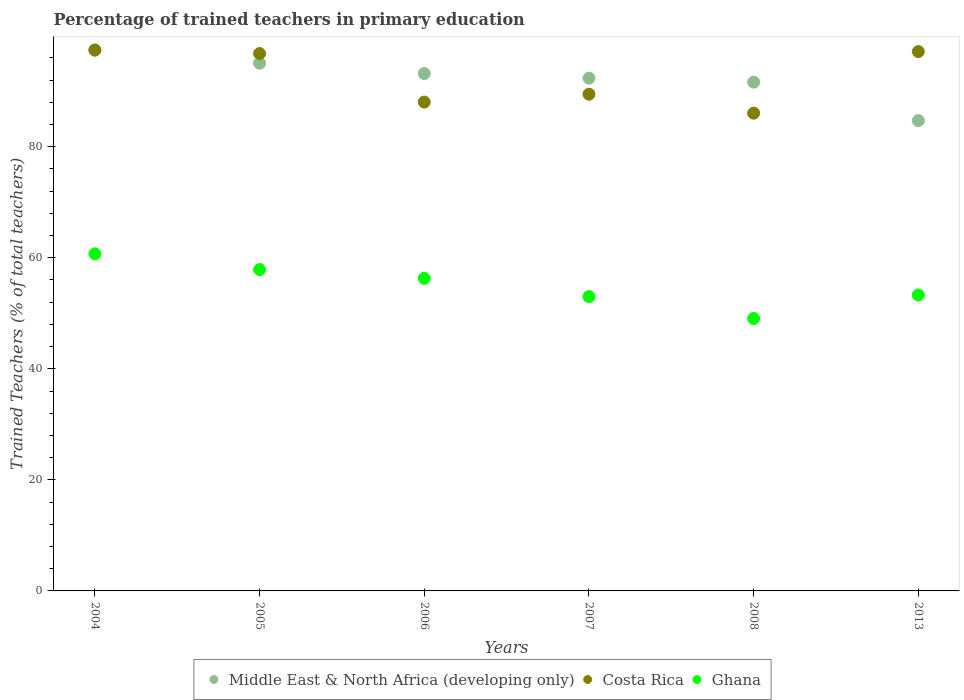What is the percentage of trained teachers in Middle East & North Africa (developing only) in 2004?
Make the answer very short. 97.4. Across all years, what is the maximum percentage of trained teachers in Ghana?
Keep it short and to the point. 60.71. Across all years, what is the minimum percentage of trained teachers in Middle East & North Africa (developing only)?
Offer a terse response. 84.71. In which year was the percentage of trained teachers in Middle East & North Africa (developing only) maximum?
Ensure brevity in your answer.  2004. In which year was the percentage of trained teachers in Middle East & North Africa (developing only) minimum?
Keep it short and to the point. 2013. What is the total percentage of trained teachers in Middle East & North Africa (developing only) in the graph?
Keep it short and to the point. 554.32. What is the difference between the percentage of trained teachers in Middle East & North Africa (developing only) in 2004 and that in 2013?
Make the answer very short. 12.69. What is the difference between the percentage of trained teachers in Costa Rica in 2004 and the percentage of trained teachers in Middle East & North Africa (developing only) in 2007?
Offer a very short reply. 5.07. What is the average percentage of trained teachers in Middle East & North Africa (developing only) per year?
Provide a short and direct response. 92.39. In the year 2013, what is the difference between the percentage of trained teachers in Middle East & North Africa (developing only) and percentage of trained teachers in Costa Rica?
Keep it short and to the point. -12.43. What is the ratio of the percentage of trained teachers in Ghana in 2006 to that in 2013?
Give a very brief answer. 1.06. Is the percentage of trained teachers in Costa Rica in 2005 less than that in 2008?
Provide a short and direct response. No. What is the difference between the highest and the second highest percentage of trained teachers in Middle East & North Africa (developing only)?
Your response must be concise. 2.35. What is the difference between the highest and the lowest percentage of trained teachers in Ghana?
Ensure brevity in your answer.  11.64. In how many years, is the percentage of trained teachers in Middle East & North Africa (developing only) greater than the average percentage of trained teachers in Middle East & North Africa (developing only) taken over all years?
Give a very brief answer. 3. Is it the case that in every year, the sum of the percentage of trained teachers in Ghana and percentage of trained teachers in Costa Rica  is greater than the percentage of trained teachers in Middle East & North Africa (developing only)?
Make the answer very short. Yes. Is the percentage of trained teachers in Costa Rica strictly greater than the percentage of trained teachers in Middle East & North Africa (developing only) over the years?
Keep it short and to the point. No. Is the percentage of trained teachers in Ghana strictly less than the percentage of trained teachers in Costa Rica over the years?
Ensure brevity in your answer.  Yes. Are the values on the major ticks of Y-axis written in scientific E-notation?
Ensure brevity in your answer.  No. Does the graph contain any zero values?
Give a very brief answer. No. Where does the legend appear in the graph?
Keep it short and to the point. Bottom center. How are the legend labels stacked?
Your answer should be very brief. Horizontal. What is the title of the graph?
Your answer should be very brief. Percentage of trained teachers in primary education. Does "Japan" appear as one of the legend labels in the graph?
Offer a terse response. No. What is the label or title of the X-axis?
Offer a terse response. Years. What is the label or title of the Y-axis?
Provide a succinct answer. Trained Teachers (% of total teachers). What is the Trained Teachers (% of total teachers) in Middle East & North Africa (developing only) in 2004?
Offer a terse response. 97.4. What is the Trained Teachers (% of total teachers) of Costa Rica in 2004?
Provide a succinct answer. 97.43. What is the Trained Teachers (% of total teachers) of Ghana in 2004?
Provide a short and direct response. 60.71. What is the Trained Teachers (% of total teachers) in Middle East & North Africa (developing only) in 2005?
Provide a succinct answer. 95.04. What is the Trained Teachers (% of total teachers) of Costa Rica in 2005?
Offer a terse response. 96.79. What is the Trained Teachers (% of total teachers) of Ghana in 2005?
Keep it short and to the point. 57.88. What is the Trained Teachers (% of total teachers) of Middle East & North Africa (developing only) in 2006?
Your answer should be very brief. 93.18. What is the Trained Teachers (% of total teachers) of Costa Rica in 2006?
Keep it short and to the point. 88.04. What is the Trained Teachers (% of total teachers) of Ghana in 2006?
Your answer should be compact. 56.3. What is the Trained Teachers (% of total teachers) of Middle East & North Africa (developing only) in 2007?
Make the answer very short. 92.36. What is the Trained Teachers (% of total teachers) in Costa Rica in 2007?
Keep it short and to the point. 89.47. What is the Trained Teachers (% of total teachers) in Ghana in 2007?
Your answer should be very brief. 53.01. What is the Trained Teachers (% of total teachers) in Middle East & North Africa (developing only) in 2008?
Give a very brief answer. 91.64. What is the Trained Teachers (% of total teachers) of Costa Rica in 2008?
Make the answer very short. 86.05. What is the Trained Teachers (% of total teachers) of Ghana in 2008?
Provide a succinct answer. 49.07. What is the Trained Teachers (% of total teachers) of Middle East & North Africa (developing only) in 2013?
Give a very brief answer. 84.71. What is the Trained Teachers (% of total teachers) of Costa Rica in 2013?
Offer a very short reply. 97.14. What is the Trained Teachers (% of total teachers) in Ghana in 2013?
Your answer should be compact. 53.3. Across all years, what is the maximum Trained Teachers (% of total teachers) in Middle East & North Africa (developing only)?
Keep it short and to the point. 97.4. Across all years, what is the maximum Trained Teachers (% of total teachers) in Costa Rica?
Make the answer very short. 97.43. Across all years, what is the maximum Trained Teachers (% of total teachers) of Ghana?
Offer a terse response. 60.71. Across all years, what is the minimum Trained Teachers (% of total teachers) in Middle East & North Africa (developing only)?
Give a very brief answer. 84.71. Across all years, what is the minimum Trained Teachers (% of total teachers) of Costa Rica?
Ensure brevity in your answer.  86.05. Across all years, what is the minimum Trained Teachers (% of total teachers) in Ghana?
Make the answer very short. 49.07. What is the total Trained Teachers (% of total teachers) in Middle East & North Africa (developing only) in the graph?
Keep it short and to the point. 554.32. What is the total Trained Teachers (% of total teachers) of Costa Rica in the graph?
Give a very brief answer. 554.91. What is the total Trained Teachers (% of total teachers) of Ghana in the graph?
Offer a terse response. 330.28. What is the difference between the Trained Teachers (% of total teachers) of Middle East & North Africa (developing only) in 2004 and that in 2005?
Your answer should be compact. 2.35. What is the difference between the Trained Teachers (% of total teachers) in Costa Rica in 2004 and that in 2005?
Offer a very short reply. 0.64. What is the difference between the Trained Teachers (% of total teachers) of Ghana in 2004 and that in 2005?
Provide a succinct answer. 2.84. What is the difference between the Trained Teachers (% of total teachers) in Middle East & North Africa (developing only) in 2004 and that in 2006?
Provide a short and direct response. 4.22. What is the difference between the Trained Teachers (% of total teachers) of Costa Rica in 2004 and that in 2006?
Provide a short and direct response. 9.38. What is the difference between the Trained Teachers (% of total teachers) in Ghana in 2004 and that in 2006?
Provide a short and direct response. 4.41. What is the difference between the Trained Teachers (% of total teachers) of Middle East & North Africa (developing only) in 2004 and that in 2007?
Give a very brief answer. 5.04. What is the difference between the Trained Teachers (% of total teachers) in Costa Rica in 2004 and that in 2007?
Provide a succinct answer. 7.96. What is the difference between the Trained Teachers (% of total teachers) in Ghana in 2004 and that in 2007?
Provide a short and direct response. 7.7. What is the difference between the Trained Teachers (% of total teachers) in Middle East & North Africa (developing only) in 2004 and that in 2008?
Give a very brief answer. 5.76. What is the difference between the Trained Teachers (% of total teachers) of Costa Rica in 2004 and that in 2008?
Give a very brief answer. 11.38. What is the difference between the Trained Teachers (% of total teachers) in Ghana in 2004 and that in 2008?
Keep it short and to the point. 11.64. What is the difference between the Trained Teachers (% of total teachers) of Middle East & North Africa (developing only) in 2004 and that in 2013?
Provide a short and direct response. 12.69. What is the difference between the Trained Teachers (% of total teachers) of Costa Rica in 2004 and that in 2013?
Give a very brief answer. 0.29. What is the difference between the Trained Teachers (% of total teachers) in Ghana in 2004 and that in 2013?
Your answer should be very brief. 7.41. What is the difference between the Trained Teachers (% of total teachers) of Middle East & North Africa (developing only) in 2005 and that in 2006?
Your answer should be compact. 1.86. What is the difference between the Trained Teachers (% of total teachers) in Costa Rica in 2005 and that in 2006?
Provide a short and direct response. 8.74. What is the difference between the Trained Teachers (% of total teachers) in Ghana in 2005 and that in 2006?
Your response must be concise. 1.57. What is the difference between the Trained Teachers (% of total teachers) of Middle East & North Africa (developing only) in 2005 and that in 2007?
Ensure brevity in your answer.  2.69. What is the difference between the Trained Teachers (% of total teachers) in Costa Rica in 2005 and that in 2007?
Ensure brevity in your answer.  7.32. What is the difference between the Trained Teachers (% of total teachers) in Ghana in 2005 and that in 2007?
Your answer should be compact. 4.86. What is the difference between the Trained Teachers (% of total teachers) in Middle East & North Africa (developing only) in 2005 and that in 2008?
Your answer should be compact. 3.41. What is the difference between the Trained Teachers (% of total teachers) of Costa Rica in 2005 and that in 2008?
Ensure brevity in your answer.  10.74. What is the difference between the Trained Teachers (% of total teachers) in Ghana in 2005 and that in 2008?
Provide a succinct answer. 8.8. What is the difference between the Trained Teachers (% of total teachers) in Middle East & North Africa (developing only) in 2005 and that in 2013?
Give a very brief answer. 10.34. What is the difference between the Trained Teachers (% of total teachers) of Costa Rica in 2005 and that in 2013?
Offer a very short reply. -0.35. What is the difference between the Trained Teachers (% of total teachers) of Ghana in 2005 and that in 2013?
Make the answer very short. 4.57. What is the difference between the Trained Teachers (% of total teachers) in Middle East & North Africa (developing only) in 2006 and that in 2007?
Keep it short and to the point. 0.82. What is the difference between the Trained Teachers (% of total teachers) in Costa Rica in 2006 and that in 2007?
Give a very brief answer. -1.42. What is the difference between the Trained Teachers (% of total teachers) in Ghana in 2006 and that in 2007?
Your answer should be very brief. 3.29. What is the difference between the Trained Teachers (% of total teachers) in Middle East & North Africa (developing only) in 2006 and that in 2008?
Keep it short and to the point. 1.54. What is the difference between the Trained Teachers (% of total teachers) of Costa Rica in 2006 and that in 2008?
Provide a succinct answer. 2. What is the difference between the Trained Teachers (% of total teachers) in Ghana in 2006 and that in 2008?
Ensure brevity in your answer.  7.23. What is the difference between the Trained Teachers (% of total teachers) in Middle East & North Africa (developing only) in 2006 and that in 2013?
Make the answer very short. 8.47. What is the difference between the Trained Teachers (% of total teachers) of Costa Rica in 2006 and that in 2013?
Your answer should be very brief. -9.1. What is the difference between the Trained Teachers (% of total teachers) of Ghana in 2006 and that in 2013?
Offer a very short reply. 3. What is the difference between the Trained Teachers (% of total teachers) of Middle East & North Africa (developing only) in 2007 and that in 2008?
Offer a terse response. 0.72. What is the difference between the Trained Teachers (% of total teachers) of Costa Rica in 2007 and that in 2008?
Your answer should be very brief. 3.42. What is the difference between the Trained Teachers (% of total teachers) in Ghana in 2007 and that in 2008?
Offer a terse response. 3.94. What is the difference between the Trained Teachers (% of total teachers) in Middle East & North Africa (developing only) in 2007 and that in 2013?
Offer a terse response. 7.65. What is the difference between the Trained Teachers (% of total teachers) in Costa Rica in 2007 and that in 2013?
Make the answer very short. -7.67. What is the difference between the Trained Teachers (% of total teachers) of Ghana in 2007 and that in 2013?
Ensure brevity in your answer.  -0.29. What is the difference between the Trained Teachers (% of total teachers) in Middle East & North Africa (developing only) in 2008 and that in 2013?
Your response must be concise. 6.93. What is the difference between the Trained Teachers (% of total teachers) of Costa Rica in 2008 and that in 2013?
Your answer should be compact. -11.09. What is the difference between the Trained Teachers (% of total teachers) of Ghana in 2008 and that in 2013?
Provide a short and direct response. -4.23. What is the difference between the Trained Teachers (% of total teachers) of Middle East & North Africa (developing only) in 2004 and the Trained Teachers (% of total teachers) of Costa Rica in 2005?
Ensure brevity in your answer.  0.61. What is the difference between the Trained Teachers (% of total teachers) in Middle East & North Africa (developing only) in 2004 and the Trained Teachers (% of total teachers) in Ghana in 2005?
Provide a short and direct response. 39.52. What is the difference between the Trained Teachers (% of total teachers) of Costa Rica in 2004 and the Trained Teachers (% of total teachers) of Ghana in 2005?
Keep it short and to the point. 39.55. What is the difference between the Trained Teachers (% of total teachers) of Middle East & North Africa (developing only) in 2004 and the Trained Teachers (% of total teachers) of Costa Rica in 2006?
Provide a succinct answer. 9.35. What is the difference between the Trained Teachers (% of total teachers) in Middle East & North Africa (developing only) in 2004 and the Trained Teachers (% of total teachers) in Ghana in 2006?
Offer a terse response. 41.09. What is the difference between the Trained Teachers (% of total teachers) of Costa Rica in 2004 and the Trained Teachers (% of total teachers) of Ghana in 2006?
Give a very brief answer. 41.12. What is the difference between the Trained Teachers (% of total teachers) of Middle East & North Africa (developing only) in 2004 and the Trained Teachers (% of total teachers) of Costa Rica in 2007?
Offer a very short reply. 7.93. What is the difference between the Trained Teachers (% of total teachers) in Middle East & North Africa (developing only) in 2004 and the Trained Teachers (% of total teachers) in Ghana in 2007?
Give a very brief answer. 44.39. What is the difference between the Trained Teachers (% of total teachers) in Costa Rica in 2004 and the Trained Teachers (% of total teachers) in Ghana in 2007?
Your answer should be compact. 44.41. What is the difference between the Trained Teachers (% of total teachers) in Middle East & North Africa (developing only) in 2004 and the Trained Teachers (% of total teachers) in Costa Rica in 2008?
Give a very brief answer. 11.35. What is the difference between the Trained Teachers (% of total teachers) in Middle East & North Africa (developing only) in 2004 and the Trained Teachers (% of total teachers) in Ghana in 2008?
Make the answer very short. 48.33. What is the difference between the Trained Teachers (% of total teachers) of Costa Rica in 2004 and the Trained Teachers (% of total teachers) of Ghana in 2008?
Offer a very short reply. 48.35. What is the difference between the Trained Teachers (% of total teachers) of Middle East & North Africa (developing only) in 2004 and the Trained Teachers (% of total teachers) of Costa Rica in 2013?
Ensure brevity in your answer.  0.26. What is the difference between the Trained Teachers (% of total teachers) in Middle East & North Africa (developing only) in 2004 and the Trained Teachers (% of total teachers) in Ghana in 2013?
Keep it short and to the point. 44.09. What is the difference between the Trained Teachers (% of total teachers) of Costa Rica in 2004 and the Trained Teachers (% of total teachers) of Ghana in 2013?
Offer a terse response. 44.12. What is the difference between the Trained Teachers (% of total teachers) in Middle East & North Africa (developing only) in 2005 and the Trained Teachers (% of total teachers) in Costa Rica in 2006?
Your answer should be very brief. 7. What is the difference between the Trained Teachers (% of total teachers) of Middle East & North Africa (developing only) in 2005 and the Trained Teachers (% of total teachers) of Ghana in 2006?
Make the answer very short. 38.74. What is the difference between the Trained Teachers (% of total teachers) of Costa Rica in 2005 and the Trained Teachers (% of total teachers) of Ghana in 2006?
Make the answer very short. 40.48. What is the difference between the Trained Teachers (% of total teachers) of Middle East & North Africa (developing only) in 2005 and the Trained Teachers (% of total teachers) of Costa Rica in 2007?
Offer a very short reply. 5.58. What is the difference between the Trained Teachers (% of total teachers) of Middle East & North Africa (developing only) in 2005 and the Trained Teachers (% of total teachers) of Ghana in 2007?
Your response must be concise. 42.03. What is the difference between the Trained Teachers (% of total teachers) in Costa Rica in 2005 and the Trained Teachers (% of total teachers) in Ghana in 2007?
Give a very brief answer. 43.78. What is the difference between the Trained Teachers (% of total teachers) of Middle East & North Africa (developing only) in 2005 and the Trained Teachers (% of total teachers) of Costa Rica in 2008?
Keep it short and to the point. 9. What is the difference between the Trained Teachers (% of total teachers) of Middle East & North Africa (developing only) in 2005 and the Trained Teachers (% of total teachers) of Ghana in 2008?
Offer a terse response. 45.97. What is the difference between the Trained Teachers (% of total teachers) of Costa Rica in 2005 and the Trained Teachers (% of total teachers) of Ghana in 2008?
Offer a terse response. 47.72. What is the difference between the Trained Teachers (% of total teachers) of Middle East & North Africa (developing only) in 2005 and the Trained Teachers (% of total teachers) of Costa Rica in 2013?
Offer a very short reply. -2.1. What is the difference between the Trained Teachers (% of total teachers) in Middle East & North Africa (developing only) in 2005 and the Trained Teachers (% of total teachers) in Ghana in 2013?
Provide a short and direct response. 41.74. What is the difference between the Trained Teachers (% of total teachers) in Costa Rica in 2005 and the Trained Teachers (% of total teachers) in Ghana in 2013?
Your answer should be very brief. 43.48. What is the difference between the Trained Teachers (% of total teachers) in Middle East & North Africa (developing only) in 2006 and the Trained Teachers (% of total teachers) in Costa Rica in 2007?
Provide a short and direct response. 3.71. What is the difference between the Trained Teachers (% of total teachers) in Middle East & North Africa (developing only) in 2006 and the Trained Teachers (% of total teachers) in Ghana in 2007?
Your response must be concise. 40.17. What is the difference between the Trained Teachers (% of total teachers) of Costa Rica in 2006 and the Trained Teachers (% of total teachers) of Ghana in 2007?
Provide a short and direct response. 35.03. What is the difference between the Trained Teachers (% of total teachers) of Middle East & North Africa (developing only) in 2006 and the Trained Teachers (% of total teachers) of Costa Rica in 2008?
Offer a very short reply. 7.13. What is the difference between the Trained Teachers (% of total teachers) of Middle East & North Africa (developing only) in 2006 and the Trained Teachers (% of total teachers) of Ghana in 2008?
Your answer should be compact. 44.11. What is the difference between the Trained Teachers (% of total teachers) of Costa Rica in 2006 and the Trained Teachers (% of total teachers) of Ghana in 2008?
Ensure brevity in your answer.  38.97. What is the difference between the Trained Teachers (% of total teachers) of Middle East & North Africa (developing only) in 2006 and the Trained Teachers (% of total teachers) of Costa Rica in 2013?
Make the answer very short. -3.96. What is the difference between the Trained Teachers (% of total teachers) in Middle East & North Africa (developing only) in 2006 and the Trained Teachers (% of total teachers) in Ghana in 2013?
Provide a short and direct response. 39.87. What is the difference between the Trained Teachers (% of total teachers) in Costa Rica in 2006 and the Trained Teachers (% of total teachers) in Ghana in 2013?
Your response must be concise. 34.74. What is the difference between the Trained Teachers (% of total teachers) of Middle East & North Africa (developing only) in 2007 and the Trained Teachers (% of total teachers) of Costa Rica in 2008?
Offer a terse response. 6.31. What is the difference between the Trained Teachers (% of total teachers) of Middle East & North Africa (developing only) in 2007 and the Trained Teachers (% of total teachers) of Ghana in 2008?
Your answer should be very brief. 43.29. What is the difference between the Trained Teachers (% of total teachers) of Costa Rica in 2007 and the Trained Teachers (% of total teachers) of Ghana in 2008?
Keep it short and to the point. 40.39. What is the difference between the Trained Teachers (% of total teachers) in Middle East & North Africa (developing only) in 2007 and the Trained Teachers (% of total teachers) in Costa Rica in 2013?
Offer a very short reply. -4.78. What is the difference between the Trained Teachers (% of total teachers) in Middle East & North Africa (developing only) in 2007 and the Trained Teachers (% of total teachers) in Ghana in 2013?
Your answer should be very brief. 39.05. What is the difference between the Trained Teachers (% of total teachers) in Costa Rica in 2007 and the Trained Teachers (% of total teachers) in Ghana in 2013?
Provide a succinct answer. 36.16. What is the difference between the Trained Teachers (% of total teachers) in Middle East & North Africa (developing only) in 2008 and the Trained Teachers (% of total teachers) in Costa Rica in 2013?
Make the answer very short. -5.5. What is the difference between the Trained Teachers (% of total teachers) of Middle East & North Africa (developing only) in 2008 and the Trained Teachers (% of total teachers) of Ghana in 2013?
Provide a short and direct response. 38.33. What is the difference between the Trained Teachers (% of total teachers) in Costa Rica in 2008 and the Trained Teachers (% of total teachers) in Ghana in 2013?
Offer a terse response. 32.74. What is the average Trained Teachers (% of total teachers) in Middle East & North Africa (developing only) per year?
Give a very brief answer. 92.39. What is the average Trained Teachers (% of total teachers) of Costa Rica per year?
Make the answer very short. 92.48. What is the average Trained Teachers (% of total teachers) in Ghana per year?
Keep it short and to the point. 55.05. In the year 2004, what is the difference between the Trained Teachers (% of total teachers) of Middle East & North Africa (developing only) and Trained Teachers (% of total teachers) of Costa Rica?
Keep it short and to the point. -0.03. In the year 2004, what is the difference between the Trained Teachers (% of total teachers) of Middle East & North Africa (developing only) and Trained Teachers (% of total teachers) of Ghana?
Ensure brevity in your answer.  36.68. In the year 2004, what is the difference between the Trained Teachers (% of total teachers) of Costa Rica and Trained Teachers (% of total teachers) of Ghana?
Keep it short and to the point. 36.71. In the year 2005, what is the difference between the Trained Teachers (% of total teachers) of Middle East & North Africa (developing only) and Trained Teachers (% of total teachers) of Costa Rica?
Keep it short and to the point. -1.74. In the year 2005, what is the difference between the Trained Teachers (% of total teachers) in Middle East & North Africa (developing only) and Trained Teachers (% of total teachers) in Ghana?
Offer a terse response. 37.17. In the year 2005, what is the difference between the Trained Teachers (% of total teachers) of Costa Rica and Trained Teachers (% of total teachers) of Ghana?
Your answer should be very brief. 38.91. In the year 2006, what is the difference between the Trained Teachers (% of total teachers) of Middle East & North Africa (developing only) and Trained Teachers (% of total teachers) of Costa Rica?
Ensure brevity in your answer.  5.13. In the year 2006, what is the difference between the Trained Teachers (% of total teachers) in Middle East & North Africa (developing only) and Trained Teachers (% of total teachers) in Ghana?
Offer a very short reply. 36.87. In the year 2006, what is the difference between the Trained Teachers (% of total teachers) in Costa Rica and Trained Teachers (% of total teachers) in Ghana?
Offer a terse response. 31.74. In the year 2007, what is the difference between the Trained Teachers (% of total teachers) of Middle East & North Africa (developing only) and Trained Teachers (% of total teachers) of Costa Rica?
Provide a succinct answer. 2.89. In the year 2007, what is the difference between the Trained Teachers (% of total teachers) of Middle East & North Africa (developing only) and Trained Teachers (% of total teachers) of Ghana?
Keep it short and to the point. 39.35. In the year 2007, what is the difference between the Trained Teachers (% of total teachers) of Costa Rica and Trained Teachers (% of total teachers) of Ghana?
Offer a terse response. 36.45. In the year 2008, what is the difference between the Trained Teachers (% of total teachers) in Middle East & North Africa (developing only) and Trained Teachers (% of total teachers) in Costa Rica?
Offer a very short reply. 5.59. In the year 2008, what is the difference between the Trained Teachers (% of total teachers) of Middle East & North Africa (developing only) and Trained Teachers (% of total teachers) of Ghana?
Your answer should be very brief. 42.57. In the year 2008, what is the difference between the Trained Teachers (% of total teachers) of Costa Rica and Trained Teachers (% of total teachers) of Ghana?
Provide a short and direct response. 36.98. In the year 2013, what is the difference between the Trained Teachers (% of total teachers) in Middle East & North Africa (developing only) and Trained Teachers (% of total teachers) in Costa Rica?
Provide a short and direct response. -12.43. In the year 2013, what is the difference between the Trained Teachers (% of total teachers) of Middle East & North Africa (developing only) and Trained Teachers (% of total teachers) of Ghana?
Offer a very short reply. 31.4. In the year 2013, what is the difference between the Trained Teachers (% of total teachers) in Costa Rica and Trained Teachers (% of total teachers) in Ghana?
Offer a terse response. 43.84. What is the ratio of the Trained Teachers (% of total teachers) in Middle East & North Africa (developing only) in 2004 to that in 2005?
Provide a succinct answer. 1.02. What is the ratio of the Trained Teachers (% of total teachers) in Costa Rica in 2004 to that in 2005?
Offer a very short reply. 1.01. What is the ratio of the Trained Teachers (% of total teachers) in Ghana in 2004 to that in 2005?
Make the answer very short. 1.05. What is the ratio of the Trained Teachers (% of total teachers) in Middle East & North Africa (developing only) in 2004 to that in 2006?
Offer a very short reply. 1.05. What is the ratio of the Trained Teachers (% of total teachers) of Costa Rica in 2004 to that in 2006?
Your answer should be compact. 1.11. What is the ratio of the Trained Teachers (% of total teachers) of Ghana in 2004 to that in 2006?
Your answer should be compact. 1.08. What is the ratio of the Trained Teachers (% of total teachers) of Middle East & North Africa (developing only) in 2004 to that in 2007?
Offer a very short reply. 1.05. What is the ratio of the Trained Teachers (% of total teachers) in Costa Rica in 2004 to that in 2007?
Provide a short and direct response. 1.09. What is the ratio of the Trained Teachers (% of total teachers) of Ghana in 2004 to that in 2007?
Your response must be concise. 1.15. What is the ratio of the Trained Teachers (% of total teachers) in Middle East & North Africa (developing only) in 2004 to that in 2008?
Make the answer very short. 1.06. What is the ratio of the Trained Teachers (% of total teachers) in Costa Rica in 2004 to that in 2008?
Offer a very short reply. 1.13. What is the ratio of the Trained Teachers (% of total teachers) in Ghana in 2004 to that in 2008?
Offer a very short reply. 1.24. What is the ratio of the Trained Teachers (% of total teachers) in Middle East & North Africa (developing only) in 2004 to that in 2013?
Keep it short and to the point. 1.15. What is the ratio of the Trained Teachers (% of total teachers) of Costa Rica in 2004 to that in 2013?
Your response must be concise. 1. What is the ratio of the Trained Teachers (% of total teachers) in Ghana in 2004 to that in 2013?
Provide a succinct answer. 1.14. What is the ratio of the Trained Teachers (% of total teachers) in Middle East & North Africa (developing only) in 2005 to that in 2006?
Give a very brief answer. 1.02. What is the ratio of the Trained Teachers (% of total teachers) in Costa Rica in 2005 to that in 2006?
Give a very brief answer. 1.1. What is the ratio of the Trained Teachers (% of total teachers) of Ghana in 2005 to that in 2006?
Your response must be concise. 1.03. What is the ratio of the Trained Teachers (% of total teachers) in Middle East & North Africa (developing only) in 2005 to that in 2007?
Your answer should be very brief. 1.03. What is the ratio of the Trained Teachers (% of total teachers) of Costa Rica in 2005 to that in 2007?
Your answer should be compact. 1.08. What is the ratio of the Trained Teachers (% of total teachers) in Ghana in 2005 to that in 2007?
Make the answer very short. 1.09. What is the ratio of the Trained Teachers (% of total teachers) in Middle East & North Africa (developing only) in 2005 to that in 2008?
Offer a terse response. 1.04. What is the ratio of the Trained Teachers (% of total teachers) in Costa Rica in 2005 to that in 2008?
Your answer should be compact. 1.12. What is the ratio of the Trained Teachers (% of total teachers) of Ghana in 2005 to that in 2008?
Ensure brevity in your answer.  1.18. What is the ratio of the Trained Teachers (% of total teachers) in Middle East & North Africa (developing only) in 2005 to that in 2013?
Give a very brief answer. 1.12. What is the ratio of the Trained Teachers (% of total teachers) in Ghana in 2005 to that in 2013?
Offer a very short reply. 1.09. What is the ratio of the Trained Teachers (% of total teachers) in Middle East & North Africa (developing only) in 2006 to that in 2007?
Offer a terse response. 1.01. What is the ratio of the Trained Teachers (% of total teachers) in Costa Rica in 2006 to that in 2007?
Your answer should be compact. 0.98. What is the ratio of the Trained Teachers (% of total teachers) of Ghana in 2006 to that in 2007?
Offer a terse response. 1.06. What is the ratio of the Trained Teachers (% of total teachers) in Middle East & North Africa (developing only) in 2006 to that in 2008?
Your answer should be compact. 1.02. What is the ratio of the Trained Teachers (% of total teachers) in Costa Rica in 2006 to that in 2008?
Give a very brief answer. 1.02. What is the ratio of the Trained Teachers (% of total teachers) in Ghana in 2006 to that in 2008?
Provide a short and direct response. 1.15. What is the ratio of the Trained Teachers (% of total teachers) of Costa Rica in 2006 to that in 2013?
Keep it short and to the point. 0.91. What is the ratio of the Trained Teachers (% of total teachers) of Ghana in 2006 to that in 2013?
Your answer should be very brief. 1.06. What is the ratio of the Trained Teachers (% of total teachers) of Middle East & North Africa (developing only) in 2007 to that in 2008?
Keep it short and to the point. 1.01. What is the ratio of the Trained Teachers (% of total teachers) in Costa Rica in 2007 to that in 2008?
Offer a terse response. 1.04. What is the ratio of the Trained Teachers (% of total teachers) in Ghana in 2007 to that in 2008?
Your answer should be compact. 1.08. What is the ratio of the Trained Teachers (% of total teachers) of Middle East & North Africa (developing only) in 2007 to that in 2013?
Keep it short and to the point. 1.09. What is the ratio of the Trained Teachers (% of total teachers) of Costa Rica in 2007 to that in 2013?
Your answer should be very brief. 0.92. What is the ratio of the Trained Teachers (% of total teachers) in Ghana in 2007 to that in 2013?
Keep it short and to the point. 0.99. What is the ratio of the Trained Teachers (% of total teachers) in Middle East & North Africa (developing only) in 2008 to that in 2013?
Offer a very short reply. 1.08. What is the ratio of the Trained Teachers (% of total teachers) in Costa Rica in 2008 to that in 2013?
Offer a very short reply. 0.89. What is the ratio of the Trained Teachers (% of total teachers) in Ghana in 2008 to that in 2013?
Give a very brief answer. 0.92. What is the difference between the highest and the second highest Trained Teachers (% of total teachers) in Middle East & North Africa (developing only)?
Make the answer very short. 2.35. What is the difference between the highest and the second highest Trained Teachers (% of total teachers) in Costa Rica?
Keep it short and to the point. 0.29. What is the difference between the highest and the second highest Trained Teachers (% of total teachers) in Ghana?
Provide a short and direct response. 2.84. What is the difference between the highest and the lowest Trained Teachers (% of total teachers) of Middle East & North Africa (developing only)?
Give a very brief answer. 12.69. What is the difference between the highest and the lowest Trained Teachers (% of total teachers) of Costa Rica?
Provide a succinct answer. 11.38. What is the difference between the highest and the lowest Trained Teachers (% of total teachers) of Ghana?
Your answer should be compact. 11.64. 